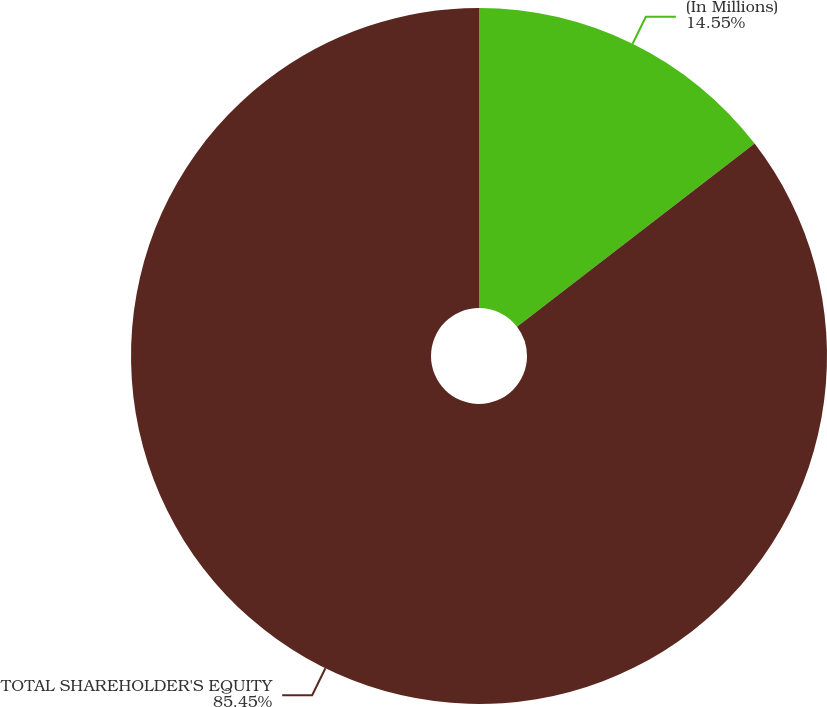Convert chart. <chart><loc_0><loc_0><loc_500><loc_500><pie_chart><fcel>(In Millions)<fcel>TOTAL SHAREHOLDER'S EQUITY<nl><fcel>14.55%<fcel>85.45%<nl></chart> 